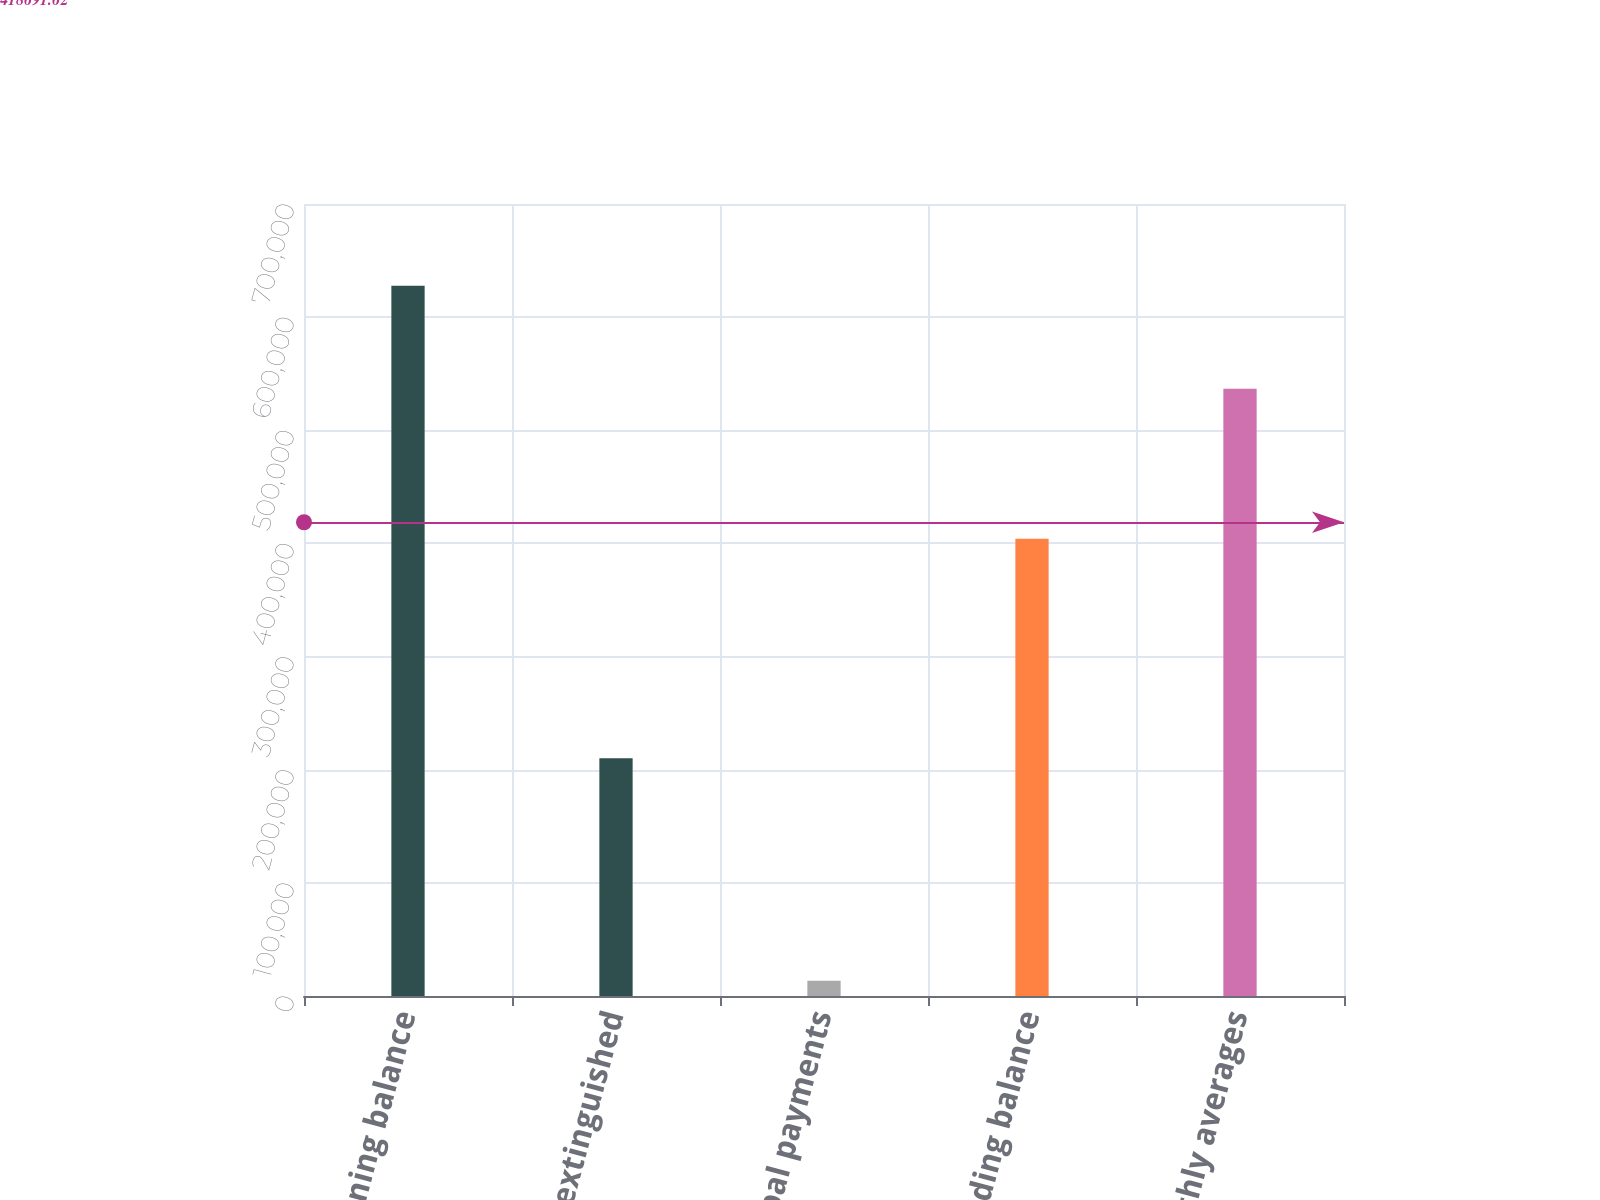Convert chart. <chart><loc_0><loc_0><loc_500><loc_500><bar_chart><fcel>Beginning balance<fcel>Debt extinguished<fcel>Principal payments<fcel>Ending balance<fcel>Monthly averages<nl><fcel>627689<fcel>210115<fcel>13495<fcel>404079<fcel>536774<nl></chart> 